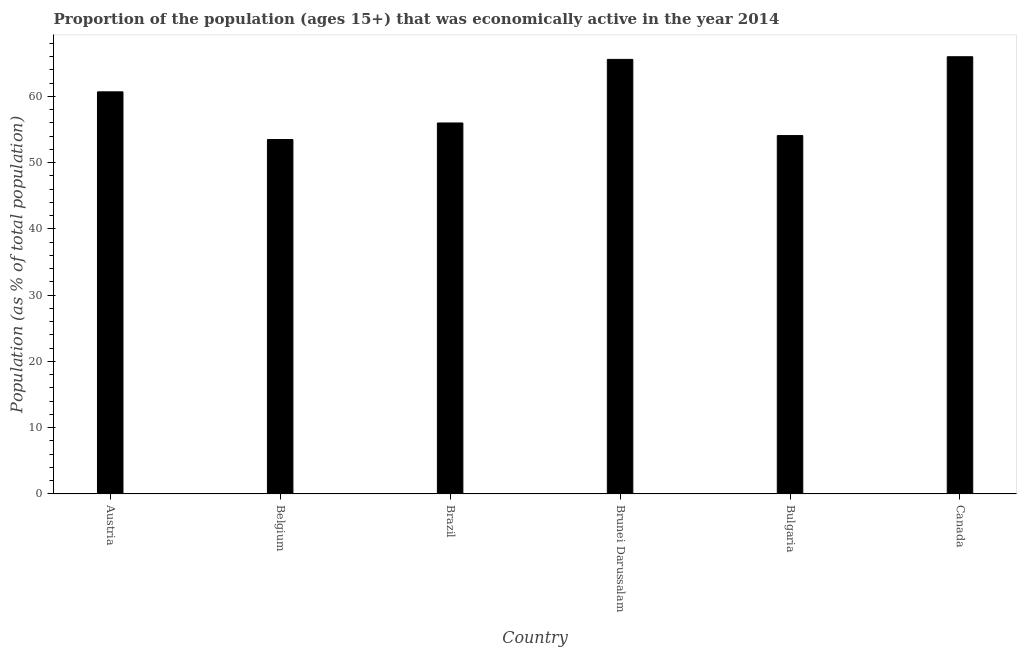Does the graph contain any zero values?
Your answer should be compact. No. What is the title of the graph?
Give a very brief answer. Proportion of the population (ages 15+) that was economically active in the year 2014. What is the label or title of the X-axis?
Your answer should be very brief. Country. What is the label or title of the Y-axis?
Offer a very short reply. Population (as % of total population). What is the percentage of economically active population in Brunei Darussalam?
Offer a terse response. 65.6. Across all countries, what is the minimum percentage of economically active population?
Provide a short and direct response. 53.5. In which country was the percentage of economically active population minimum?
Provide a succinct answer. Belgium. What is the sum of the percentage of economically active population?
Ensure brevity in your answer.  355.9. What is the average percentage of economically active population per country?
Your answer should be compact. 59.32. What is the median percentage of economically active population?
Your response must be concise. 58.35. In how many countries, is the percentage of economically active population greater than 12 %?
Offer a terse response. 6. What is the ratio of the percentage of economically active population in Brazil to that in Bulgaria?
Offer a terse response. 1.03. What is the difference between the highest and the second highest percentage of economically active population?
Provide a succinct answer. 0.4. What is the difference between the highest and the lowest percentage of economically active population?
Offer a terse response. 12.5. In how many countries, is the percentage of economically active population greater than the average percentage of economically active population taken over all countries?
Provide a succinct answer. 3. How many bars are there?
Offer a terse response. 6. How many countries are there in the graph?
Offer a very short reply. 6. What is the difference between two consecutive major ticks on the Y-axis?
Offer a terse response. 10. Are the values on the major ticks of Y-axis written in scientific E-notation?
Keep it short and to the point. No. What is the Population (as % of total population) in Austria?
Keep it short and to the point. 60.7. What is the Population (as % of total population) of Belgium?
Offer a terse response. 53.5. What is the Population (as % of total population) in Brazil?
Give a very brief answer. 56. What is the Population (as % of total population) of Brunei Darussalam?
Offer a very short reply. 65.6. What is the Population (as % of total population) of Bulgaria?
Provide a short and direct response. 54.1. What is the difference between the Population (as % of total population) in Austria and Brazil?
Ensure brevity in your answer.  4.7. What is the difference between the Population (as % of total population) in Belgium and Brazil?
Provide a short and direct response. -2.5. What is the difference between the Population (as % of total population) in Belgium and Brunei Darussalam?
Provide a short and direct response. -12.1. What is the difference between the Population (as % of total population) in Belgium and Canada?
Offer a terse response. -12.5. What is the difference between the Population (as % of total population) in Brazil and Bulgaria?
Offer a very short reply. 1.9. What is the difference between the Population (as % of total population) in Brazil and Canada?
Ensure brevity in your answer.  -10. What is the difference between the Population (as % of total population) in Brunei Darussalam and Bulgaria?
Keep it short and to the point. 11.5. What is the difference between the Population (as % of total population) in Brunei Darussalam and Canada?
Keep it short and to the point. -0.4. What is the difference between the Population (as % of total population) in Bulgaria and Canada?
Provide a short and direct response. -11.9. What is the ratio of the Population (as % of total population) in Austria to that in Belgium?
Your response must be concise. 1.14. What is the ratio of the Population (as % of total population) in Austria to that in Brazil?
Give a very brief answer. 1.08. What is the ratio of the Population (as % of total population) in Austria to that in Brunei Darussalam?
Ensure brevity in your answer.  0.93. What is the ratio of the Population (as % of total population) in Austria to that in Bulgaria?
Your answer should be very brief. 1.12. What is the ratio of the Population (as % of total population) in Austria to that in Canada?
Ensure brevity in your answer.  0.92. What is the ratio of the Population (as % of total population) in Belgium to that in Brazil?
Give a very brief answer. 0.95. What is the ratio of the Population (as % of total population) in Belgium to that in Brunei Darussalam?
Provide a short and direct response. 0.82. What is the ratio of the Population (as % of total population) in Belgium to that in Canada?
Provide a succinct answer. 0.81. What is the ratio of the Population (as % of total population) in Brazil to that in Brunei Darussalam?
Provide a succinct answer. 0.85. What is the ratio of the Population (as % of total population) in Brazil to that in Bulgaria?
Your answer should be very brief. 1.03. What is the ratio of the Population (as % of total population) in Brazil to that in Canada?
Keep it short and to the point. 0.85. What is the ratio of the Population (as % of total population) in Brunei Darussalam to that in Bulgaria?
Offer a terse response. 1.21. What is the ratio of the Population (as % of total population) in Bulgaria to that in Canada?
Ensure brevity in your answer.  0.82. 